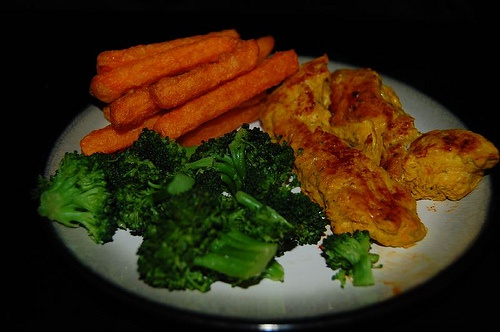Describe the objects in this image and their specific colors. I can see broccoli in black, darkgreen, and maroon tones, carrot in black, maroon, and brown tones, broccoli in black, darkgreen, and olive tones, and carrot in black and maroon tones in this image. 